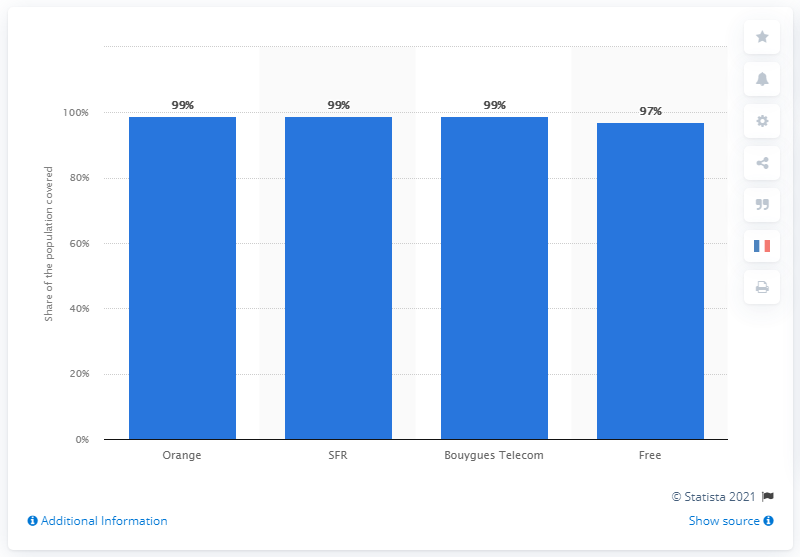Highlight a few significant elements in this photo. Orange, a company, provided 4G coverage that benefited 99% of the French population in September 2020. 